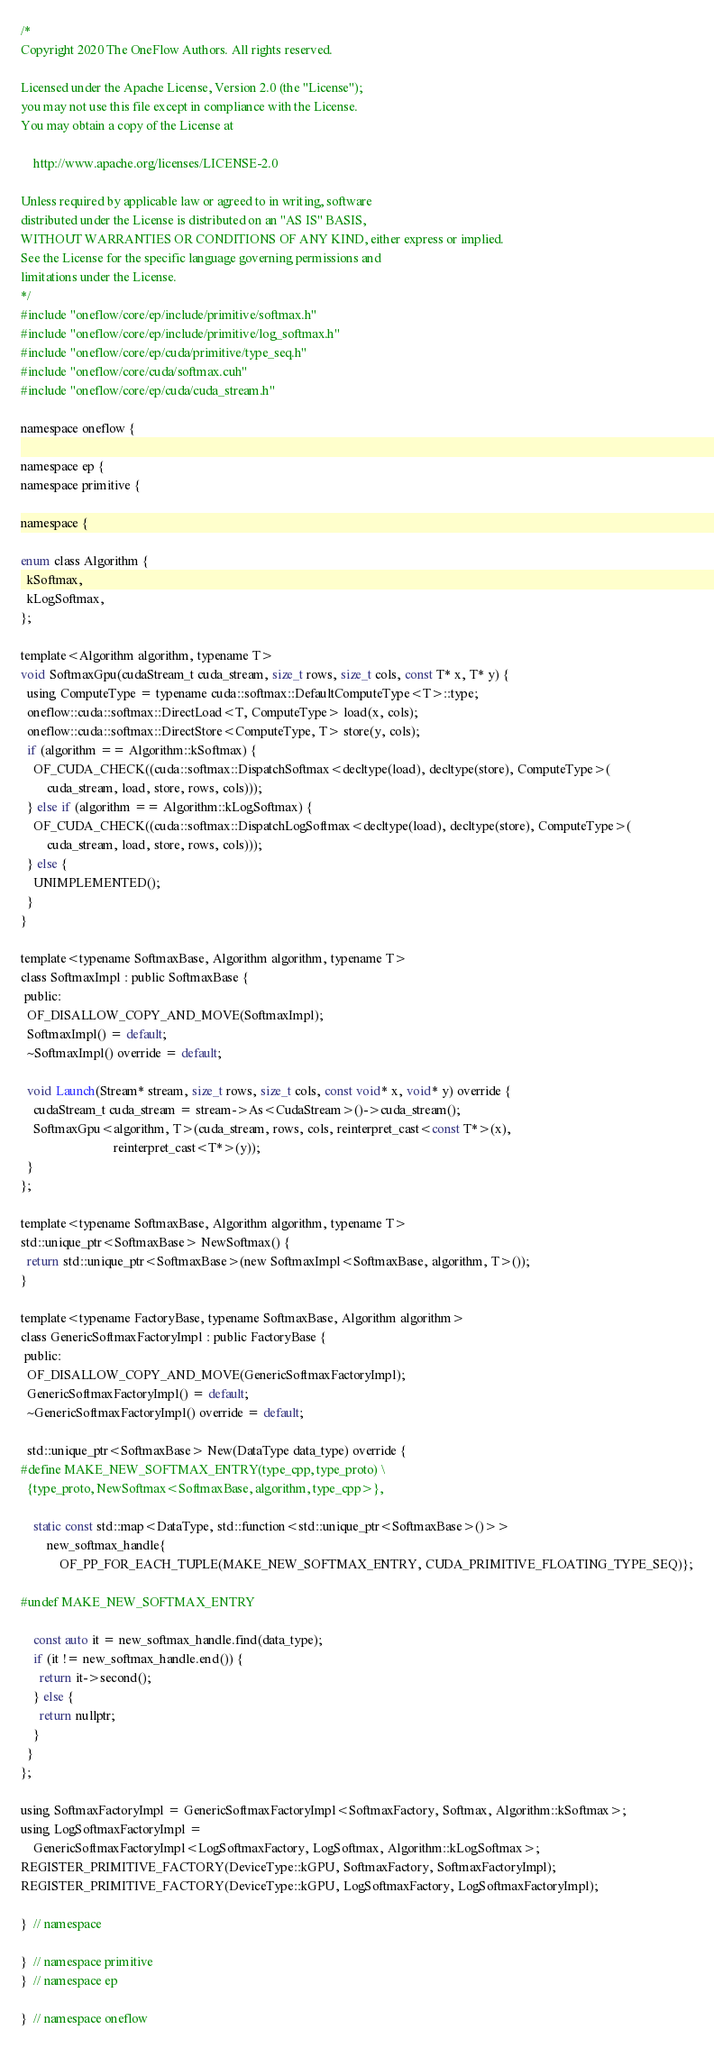<code> <loc_0><loc_0><loc_500><loc_500><_Cuda_>/*
Copyright 2020 The OneFlow Authors. All rights reserved.

Licensed under the Apache License, Version 2.0 (the "License");
you may not use this file except in compliance with the License.
You may obtain a copy of the License at

    http://www.apache.org/licenses/LICENSE-2.0

Unless required by applicable law or agreed to in writing, software
distributed under the License is distributed on an "AS IS" BASIS,
WITHOUT WARRANTIES OR CONDITIONS OF ANY KIND, either express or implied.
See the License for the specific language governing permissions and
limitations under the License.
*/
#include "oneflow/core/ep/include/primitive/softmax.h"
#include "oneflow/core/ep/include/primitive/log_softmax.h"
#include "oneflow/core/ep/cuda/primitive/type_seq.h"
#include "oneflow/core/cuda/softmax.cuh"
#include "oneflow/core/ep/cuda/cuda_stream.h"

namespace oneflow {

namespace ep {
namespace primitive {

namespace {

enum class Algorithm {
  kSoftmax,
  kLogSoftmax,
};

template<Algorithm algorithm, typename T>
void SoftmaxGpu(cudaStream_t cuda_stream, size_t rows, size_t cols, const T* x, T* y) {
  using ComputeType = typename cuda::softmax::DefaultComputeType<T>::type;
  oneflow::cuda::softmax::DirectLoad<T, ComputeType> load(x, cols);
  oneflow::cuda::softmax::DirectStore<ComputeType, T> store(y, cols);
  if (algorithm == Algorithm::kSoftmax) {
    OF_CUDA_CHECK((cuda::softmax::DispatchSoftmax<decltype(load), decltype(store), ComputeType>(
        cuda_stream, load, store, rows, cols)));
  } else if (algorithm == Algorithm::kLogSoftmax) {
    OF_CUDA_CHECK((cuda::softmax::DispatchLogSoftmax<decltype(load), decltype(store), ComputeType>(
        cuda_stream, load, store, rows, cols)));
  } else {
    UNIMPLEMENTED();
  }
}

template<typename SoftmaxBase, Algorithm algorithm, typename T>
class SoftmaxImpl : public SoftmaxBase {
 public:
  OF_DISALLOW_COPY_AND_MOVE(SoftmaxImpl);
  SoftmaxImpl() = default;
  ~SoftmaxImpl() override = default;

  void Launch(Stream* stream, size_t rows, size_t cols, const void* x, void* y) override {
    cudaStream_t cuda_stream = stream->As<CudaStream>()->cuda_stream();
    SoftmaxGpu<algorithm, T>(cuda_stream, rows, cols, reinterpret_cast<const T*>(x),
                             reinterpret_cast<T*>(y));
  }
};

template<typename SoftmaxBase, Algorithm algorithm, typename T>
std::unique_ptr<SoftmaxBase> NewSoftmax() {
  return std::unique_ptr<SoftmaxBase>(new SoftmaxImpl<SoftmaxBase, algorithm, T>());
}

template<typename FactoryBase, typename SoftmaxBase, Algorithm algorithm>
class GenericSoftmaxFactoryImpl : public FactoryBase {
 public:
  OF_DISALLOW_COPY_AND_MOVE(GenericSoftmaxFactoryImpl);
  GenericSoftmaxFactoryImpl() = default;
  ~GenericSoftmaxFactoryImpl() override = default;

  std::unique_ptr<SoftmaxBase> New(DataType data_type) override {
#define MAKE_NEW_SOFTMAX_ENTRY(type_cpp, type_proto) \
  {type_proto, NewSoftmax<SoftmaxBase, algorithm, type_cpp>},

    static const std::map<DataType, std::function<std::unique_ptr<SoftmaxBase>()>>
        new_softmax_handle{
            OF_PP_FOR_EACH_TUPLE(MAKE_NEW_SOFTMAX_ENTRY, CUDA_PRIMITIVE_FLOATING_TYPE_SEQ)};

#undef MAKE_NEW_SOFTMAX_ENTRY

    const auto it = new_softmax_handle.find(data_type);
    if (it != new_softmax_handle.end()) {
      return it->second();
    } else {
      return nullptr;
    }
  }
};

using SoftmaxFactoryImpl = GenericSoftmaxFactoryImpl<SoftmaxFactory, Softmax, Algorithm::kSoftmax>;
using LogSoftmaxFactoryImpl =
    GenericSoftmaxFactoryImpl<LogSoftmaxFactory, LogSoftmax, Algorithm::kLogSoftmax>;
REGISTER_PRIMITIVE_FACTORY(DeviceType::kGPU, SoftmaxFactory, SoftmaxFactoryImpl);
REGISTER_PRIMITIVE_FACTORY(DeviceType::kGPU, LogSoftmaxFactory, LogSoftmaxFactoryImpl);

}  // namespace

}  // namespace primitive
}  // namespace ep

}  // namespace oneflow
</code> 